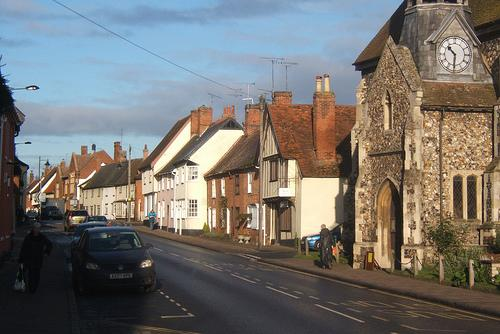What is the person on the left standing next to?

Choices:
A) airplane
B) car
C) baby
D) umbrella car 